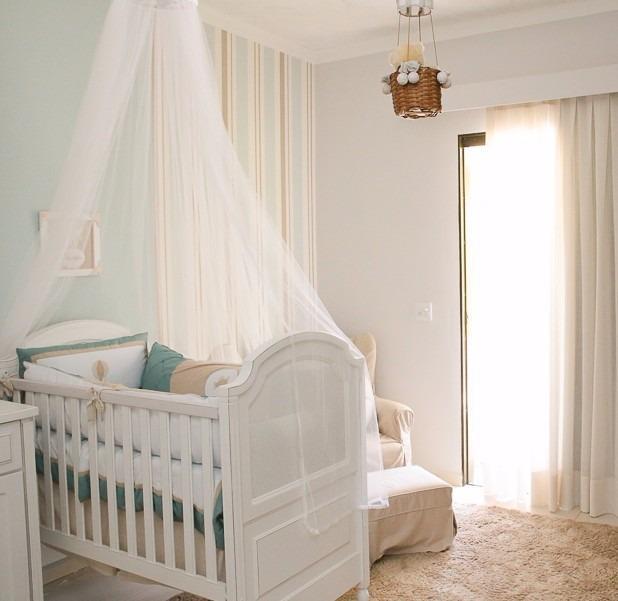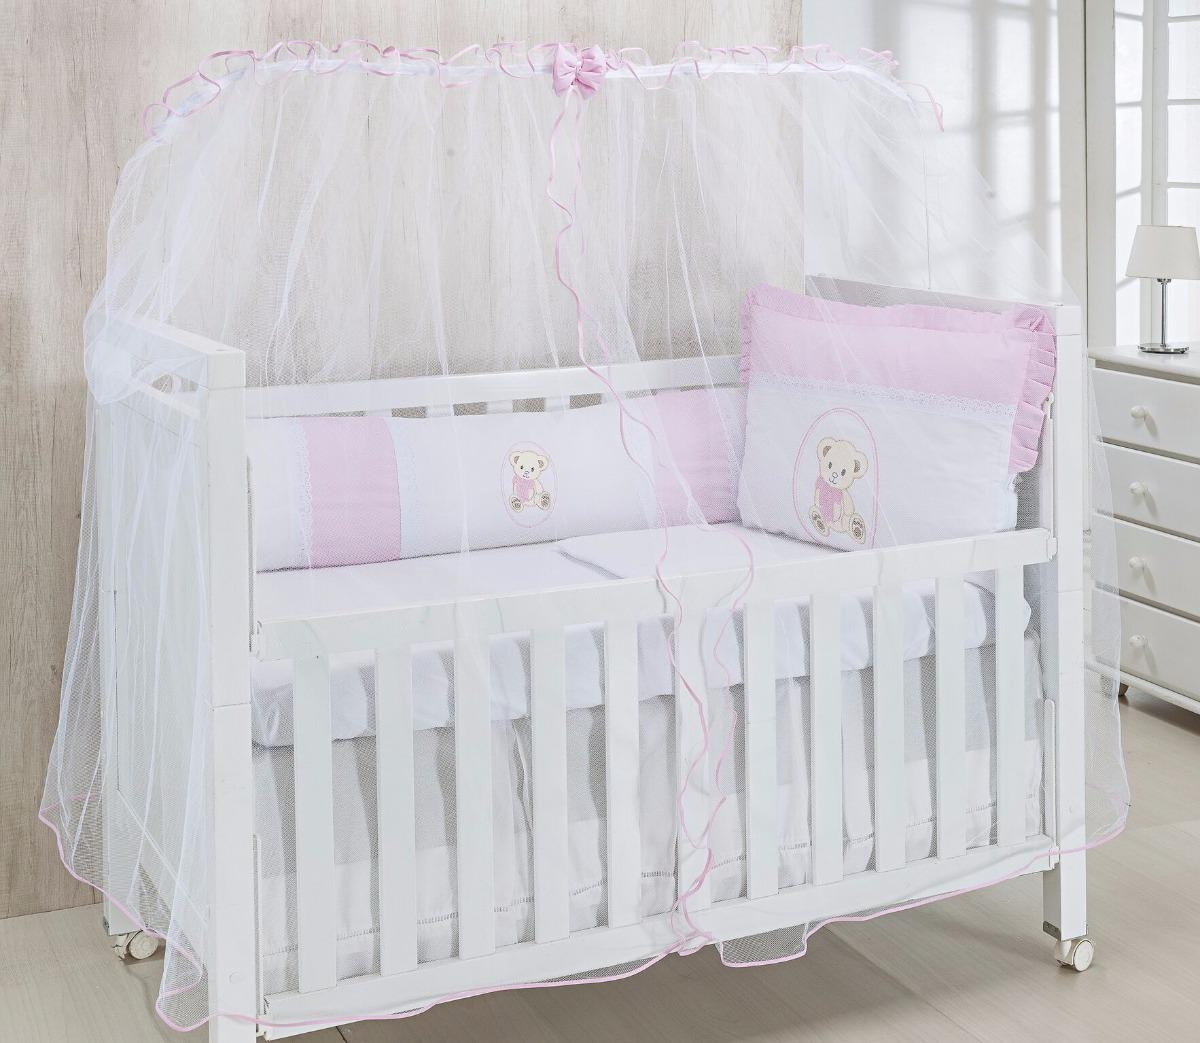The first image is the image on the left, the second image is the image on the right. For the images displayed, is the sentence "There are two canopies and at least one is a tent." factually correct? Answer yes or no. No. The first image is the image on the left, the second image is the image on the right. Considering the images on both sides, is "A tented net covers a sleeping area with a stuffed animal in the image on the right." valid? Answer yes or no. No. 